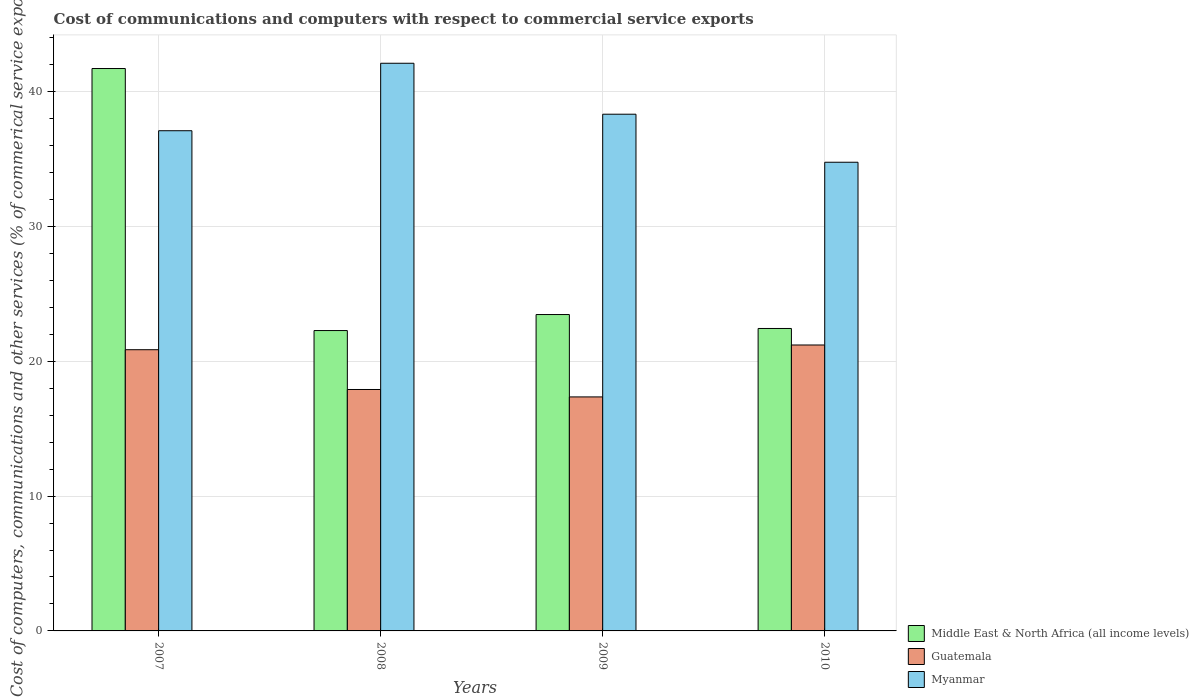How many groups of bars are there?
Your response must be concise. 4. What is the label of the 2nd group of bars from the left?
Keep it short and to the point. 2008. In how many cases, is the number of bars for a given year not equal to the number of legend labels?
Keep it short and to the point. 0. What is the cost of communications and computers in Guatemala in 2010?
Ensure brevity in your answer.  21.21. Across all years, what is the maximum cost of communications and computers in Myanmar?
Your response must be concise. 42.11. Across all years, what is the minimum cost of communications and computers in Middle East & North Africa (all income levels)?
Your answer should be very brief. 22.28. In which year was the cost of communications and computers in Myanmar minimum?
Provide a succinct answer. 2010. What is the total cost of communications and computers in Guatemala in the graph?
Your response must be concise. 77.34. What is the difference between the cost of communications and computers in Myanmar in 2008 and that in 2010?
Offer a very short reply. 7.34. What is the difference between the cost of communications and computers in Myanmar in 2008 and the cost of communications and computers in Middle East & North Africa (all income levels) in 2010?
Your answer should be very brief. 19.67. What is the average cost of communications and computers in Myanmar per year?
Make the answer very short. 38.08. In the year 2010, what is the difference between the cost of communications and computers in Myanmar and cost of communications and computers in Guatemala?
Your answer should be very brief. 13.56. In how many years, is the cost of communications and computers in Myanmar greater than 28 %?
Your response must be concise. 4. What is the ratio of the cost of communications and computers in Myanmar in 2008 to that in 2009?
Your response must be concise. 1.1. Is the cost of communications and computers in Myanmar in 2007 less than that in 2010?
Your answer should be very brief. No. Is the difference between the cost of communications and computers in Myanmar in 2007 and 2009 greater than the difference between the cost of communications and computers in Guatemala in 2007 and 2009?
Your response must be concise. No. What is the difference between the highest and the second highest cost of communications and computers in Myanmar?
Make the answer very short. 3.78. What is the difference between the highest and the lowest cost of communications and computers in Middle East & North Africa (all income levels)?
Your answer should be compact. 19.44. What does the 2nd bar from the left in 2010 represents?
Keep it short and to the point. Guatemala. What does the 2nd bar from the right in 2010 represents?
Your answer should be very brief. Guatemala. How many bars are there?
Your response must be concise. 12. Are all the bars in the graph horizontal?
Offer a terse response. No. How many years are there in the graph?
Provide a succinct answer. 4. Are the values on the major ticks of Y-axis written in scientific E-notation?
Your answer should be very brief. No. Does the graph contain grids?
Offer a very short reply. Yes. How are the legend labels stacked?
Your answer should be very brief. Vertical. What is the title of the graph?
Your response must be concise. Cost of communications and computers with respect to commercial service exports. What is the label or title of the X-axis?
Provide a succinct answer. Years. What is the label or title of the Y-axis?
Your answer should be compact. Cost of computers, communications and other services (% of commerical service exports). What is the Cost of computers, communications and other services (% of commerical service exports) in Middle East & North Africa (all income levels) in 2007?
Provide a short and direct response. 41.72. What is the Cost of computers, communications and other services (% of commerical service exports) of Guatemala in 2007?
Offer a very short reply. 20.86. What is the Cost of computers, communications and other services (% of commerical service exports) in Myanmar in 2007?
Provide a succinct answer. 37.11. What is the Cost of computers, communications and other services (% of commerical service exports) in Middle East & North Africa (all income levels) in 2008?
Provide a short and direct response. 22.28. What is the Cost of computers, communications and other services (% of commerical service exports) in Guatemala in 2008?
Provide a short and direct response. 17.91. What is the Cost of computers, communications and other services (% of commerical service exports) of Myanmar in 2008?
Keep it short and to the point. 42.11. What is the Cost of computers, communications and other services (% of commerical service exports) of Middle East & North Africa (all income levels) in 2009?
Give a very brief answer. 23.47. What is the Cost of computers, communications and other services (% of commerical service exports) in Guatemala in 2009?
Give a very brief answer. 17.36. What is the Cost of computers, communications and other services (% of commerical service exports) of Myanmar in 2009?
Provide a short and direct response. 38.33. What is the Cost of computers, communications and other services (% of commerical service exports) of Middle East & North Africa (all income levels) in 2010?
Your response must be concise. 22.44. What is the Cost of computers, communications and other services (% of commerical service exports) in Guatemala in 2010?
Give a very brief answer. 21.21. What is the Cost of computers, communications and other services (% of commerical service exports) in Myanmar in 2010?
Make the answer very short. 34.77. Across all years, what is the maximum Cost of computers, communications and other services (% of commerical service exports) in Middle East & North Africa (all income levels)?
Give a very brief answer. 41.72. Across all years, what is the maximum Cost of computers, communications and other services (% of commerical service exports) in Guatemala?
Ensure brevity in your answer.  21.21. Across all years, what is the maximum Cost of computers, communications and other services (% of commerical service exports) in Myanmar?
Keep it short and to the point. 42.11. Across all years, what is the minimum Cost of computers, communications and other services (% of commerical service exports) of Middle East & North Africa (all income levels)?
Keep it short and to the point. 22.28. Across all years, what is the minimum Cost of computers, communications and other services (% of commerical service exports) in Guatemala?
Provide a succinct answer. 17.36. Across all years, what is the minimum Cost of computers, communications and other services (% of commerical service exports) in Myanmar?
Offer a terse response. 34.77. What is the total Cost of computers, communications and other services (% of commerical service exports) in Middle East & North Africa (all income levels) in the graph?
Offer a very short reply. 109.91. What is the total Cost of computers, communications and other services (% of commerical service exports) in Guatemala in the graph?
Ensure brevity in your answer.  77.34. What is the total Cost of computers, communications and other services (% of commerical service exports) of Myanmar in the graph?
Ensure brevity in your answer.  152.31. What is the difference between the Cost of computers, communications and other services (% of commerical service exports) in Middle East & North Africa (all income levels) in 2007 and that in 2008?
Your answer should be compact. 19.44. What is the difference between the Cost of computers, communications and other services (% of commerical service exports) of Guatemala in 2007 and that in 2008?
Your response must be concise. 2.95. What is the difference between the Cost of computers, communications and other services (% of commerical service exports) of Myanmar in 2007 and that in 2008?
Provide a short and direct response. -5.01. What is the difference between the Cost of computers, communications and other services (% of commerical service exports) of Middle East & North Africa (all income levels) in 2007 and that in 2009?
Ensure brevity in your answer.  18.25. What is the difference between the Cost of computers, communications and other services (% of commerical service exports) in Guatemala in 2007 and that in 2009?
Provide a short and direct response. 3.5. What is the difference between the Cost of computers, communications and other services (% of commerical service exports) of Myanmar in 2007 and that in 2009?
Keep it short and to the point. -1.23. What is the difference between the Cost of computers, communications and other services (% of commerical service exports) of Middle East & North Africa (all income levels) in 2007 and that in 2010?
Your answer should be very brief. 19.28. What is the difference between the Cost of computers, communications and other services (% of commerical service exports) of Guatemala in 2007 and that in 2010?
Give a very brief answer. -0.35. What is the difference between the Cost of computers, communications and other services (% of commerical service exports) in Myanmar in 2007 and that in 2010?
Make the answer very short. 2.34. What is the difference between the Cost of computers, communications and other services (% of commerical service exports) of Middle East & North Africa (all income levels) in 2008 and that in 2009?
Your answer should be compact. -1.19. What is the difference between the Cost of computers, communications and other services (% of commerical service exports) in Guatemala in 2008 and that in 2009?
Ensure brevity in your answer.  0.55. What is the difference between the Cost of computers, communications and other services (% of commerical service exports) of Myanmar in 2008 and that in 2009?
Provide a succinct answer. 3.78. What is the difference between the Cost of computers, communications and other services (% of commerical service exports) of Middle East & North Africa (all income levels) in 2008 and that in 2010?
Give a very brief answer. -0.15. What is the difference between the Cost of computers, communications and other services (% of commerical service exports) of Guatemala in 2008 and that in 2010?
Give a very brief answer. -3.3. What is the difference between the Cost of computers, communications and other services (% of commerical service exports) of Myanmar in 2008 and that in 2010?
Your response must be concise. 7.34. What is the difference between the Cost of computers, communications and other services (% of commerical service exports) in Guatemala in 2009 and that in 2010?
Offer a very short reply. -3.85. What is the difference between the Cost of computers, communications and other services (% of commerical service exports) in Myanmar in 2009 and that in 2010?
Ensure brevity in your answer.  3.56. What is the difference between the Cost of computers, communications and other services (% of commerical service exports) of Middle East & North Africa (all income levels) in 2007 and the Cost of computers, communications and other services (% of commerical service exports) of Guatemala in 2008?
Your response must be concise. 23.81. What is the difference between the Cost of computers, communications and other services (% of commerical service exports) in Middle East & North Africa (all income levels) in 2007 and the Cost of computers, communications and other services (% of commerical service exports) in Myanmar in 2008?
Provide a succinct answer. -0.39. What is the difference between the Cost of computers, communications and other services (% of commerical service exports) of Guatemala in 2007 and the Cost of computers, communications and other services (% of commerical service exports) of Myanmar in 2008?
Keep it short and to the point. -21.25. What is the difference between the Cost of computers, communications and other services (% of commerical service exports) of Middle East & North Africa (all income levels) in 2007 and the Cost of computers, communications and other services (% of commerical service exports) of Guatemala in 2009?
Give a very brief answer. 24.36. What is the difference between the Cost of computers, communications and other services (% of commerical service exports) in Middle East & North Africa (all income levels) in 2007 and the Cost of computers, communications and other services (% of commerical service exports) in Myanmar in 2009?
Ensure brevity in your answer.  3.39. What is the difference between the Cost of computers, communications and other services (% of commerical service exports) in Guatemala in 2007 and the Cost of computers, communications and other services (% of commerical service exports) in Myanmar in 2009?
Offer a terse response. -17.47. What is the difference between the Cost of computers, communications and other services (% of commerical service exports) of Middle East & North Africa (all income levels) in 2007 and the Cost of computers, communications and other services (% of commerical service exports) of Guatemala in 2010?
Your response must be concise. 20.51. What is the difference between the Cost of computers, communications and other services (% of commerical service exports) of Middle East & North Africa (all income levels) in 2007 and the Cost of computers, communications and other services (% of commerical service exports) of Myanmar in 2010?
Give a very brief answer. 6.95. What is the difference between the Cost of computers, communications and other services (% of commerical service exports) in Guatemala in 2007 and the Cost of computers, communications and other services (% of commerical service exports) in Myanmar in 2010?
Provide a short and direct response. -13.91. What is the difference between the Cost of computers, communications and other services (% of commerical service exports) of Middle East & North Africa (all income levels) in 2008 and the Cost of computers, communications and other services (% of commerical service exports) of Guatemala in 2009?
Your answer should be very brief. 4.92. What is the difference between the Cost of computers, communications and other services (% of commerical service exports) in Middle East & North Africa (all income levels) in 2008 and the Cost of computers, communications and other services (% of commerical service exports) in Myanmar in 2009?
Provide a short and direct response. -16.05. What is the difference between the Cost of computers, communications and other services (% of commerical service exports) in Guatemala in 2008 and the Cost of computers, communications and other services (% of commerical service exports) in Myanmar in 2009?
Provide a succinct answer. -20.42. What is the difference between the Cost of computers, communications and other services (% of commerical service exports) of Middle East & North Africa (all income levels) in 2008 and the Cost of computers, communications and other services (% of commerical service exports) of Guatemala in 2010?
Give a very brief answer. 1.07. What is the difference between the Cost of computers, communications and other services (% of commerical service exports) in Middle East & North Africa (all income levels) in 2008 and the Cost of computers, communications and other services (% of commerical service exports) in Myanmar in 2010?
Your response must be concise. -12.48. What is the difference between the Cost of computers, communications and other services (% of commerical service exports) in Guatemala in 2008 and the Cost of computers, communications and other services (% of commerical service exports) in Myanmar in 2010?
Your answer should be compact. -16.86. What is the difference between the Cost of computers, communications and other services (% of commerical service exports) in Middle East & North Africa (all income levels) in 2009 and the Cost of computers, communications and other services (% of commerical service exports) in Guatemala in 2010?
Provide a short and direct response. 2.26. What is the difference between the Cost of computers, communications and other services (% of commerical service exports) in Middle East & North Africa (all income levels) in 2009 and the Cost of computers, communications and other services (% of commerical service exports) in Myanmar in 2010?
Your response must be concise. -11.3. What is the difference between the Cost of computers, communications and other services (% of commerical service exports) in Guatemala in 2009 and the Cost of computers, communications and other services (% of commerical service exports) in Myanmar in 2010?
Keep it short and to the point. -17.41. What is the average Cost of computers, communications and other services (% of commerical service exports) in Middle East & North Africa (all income levels) per year?
Your answer should be compact. 27.48. What is the average Cost of computers, communications and other services (% of commerical service exports) in Guatemala per year?
Provide a succinct answer. 19.34. What is the average Cost of computers, communications and other services (% of commerical service exports) of Myanmar per year?
Keep it short and to the point. 38.08. In the year 2007, what is the difference between the Cost of computers, communications and other services (% of commerical service exports) of Middle East & North Africa (all income levels) and Cost of computers, communications and other services (% of commerical service exports) of Guatemala?
Your response must be concise. 20.86. In the year 2007, what is the difference between the Cost of computers, communications and other services (% of commerical service exports) of Middle East & North Africa (all income levels) and Cost of computers, communications and other services (% of commerical service exports) of Myanmar?
Provide a short and direct response. 4.62. In the year 2007, what is the difference between the Cost of computers, communications and other services (% of commerical service exports) in Guatemala and Cost of computers, communications and other services (% of commerical service exports) in Myanmar?
Make the answer very short. -16.24. In the year 2008, what is the difference between the Cost of computers, communications and other services (% of commerical service exports) in Middle East & North Africa (all income levels) and Cost of computers, communications and other services (% of commerical service exports) in Guatemala?
Your response must be concise. 4.37. In the year 2008, what is the difference between the Cost of computers, communications and other services (% of commerical service exports) of Middle East & North Africa (all income levels) and Cost of computers, communications and other services (% of commerical service exports) of Myanmar?
Keep it short and to the point. -19.83. In the year 2008, what is the difference between the Cost of computers, communications and other services (% of commerical service exports) in Guatemala and Cost of computers, communications and other services (% of commerical service exports) in Myanmar?
Offer a very short reply. -24.2. In the year 2009, what is the difference between the Cost of computers, communications and other services (% of commerical service exports) of Middle East & North Africa (all income levels) and Cost of computers, communications and other services (% of commerical service exports) of Guatemala?
Provide a short and direct response. 6.11. In the year 2009, what is the difference between the Cost of computers, communications and other services (% of commerical service exports) of Middle East & North Africa (all income levels) and Cost of computers, communications and other services (% of commerical service exports) of Myanmar?
Your response must be concise. -14.86. In the year 2009, what is the difference between the Cost of computers, communications and other services (% of commerical service exports) of Guatemala and Cost of computers, communications and other services (% of commerical service exports) of Myanmar?
Make the answer very short. -20.97. In the year 2010, what is the difference between the Cost of computers, communications and other services (% of commerical service exports) of Middle East & North Africa (all income levels) and Cost of computers, communications and other services (% of commerical service exports) of Guatemala?
Keep it short and to the point. 1.23. In the year 2010, what is the difference between the Cost of computers, communications and other services (% of commerical service exports) in Middle East & North Africa (all income levels) and Cost of computers, communications and other services (% of commerical service exports) in Myanmar?
Your answer should be compact. -12.33. In the year 2010, what is the difference between the Cost of computers, communications and other services (% of commerical service exports) of Guatemala and Cost of computers, communications and other services (% of commerical service exports) of Myanmar?
Provide a short and direct response. -13.56. What is the ratio of the Cost of computers, communications and other services (% of commerical service exports) of Middle East & North Africa (all income levels) in 2007 to that in 2008?
Offer a very short reply. 1.87. What is the ratio of the Cost of computers, communications and other services (% of commerical service exports) of Guatemala in 2007 to that in 2008?
Ensure brevity in your answer.  1.16. What is the ratio of the Cost of computers, communications and other services (% of commerical service exports) of Myanmar in 2007 to that in 2008?
Your response must be concise. 0.88. What is the ratio of the Cost of computers, communications and other services (% of commerical service exports) in Middle East & North Africa (all income levels) in 2007 to that in 2009?
Give a very brief answer. 1.78. What is the ratio of the Cost of computers, communications and other services (% of commerical service exports) of Guatemala in 2007 to that in 2009?
Ensure brevity in your answer.  1.2. What is the ratio of the Cost of computers, communications and other services (% of commerical service exports) in Middle East & North Africa (all income levels) in 2007 to that in 2010?
Give a very brief answer. 1.86. What is the ratio of the Cost of computers, communications and other services (% of commerical service exports) in Guatemala in 2007 to that in 2010?
Your answer should be compact. 0.98. What is the ratio of the Cost of computers, communications and other services (% of commerical service exports) in Myanmar in 2007 to that in 2010?
Give a very brief answer. 1.07. What is the ratio of the Cost of computers, communications and other services (% of commerical service exports) in Middle East & North Africa (all income levels) in 2008 to that in 2009?
Give a very brief answer. 0.95. What is the ratio of the Cost of computers, communications and other services (% of commerical service exports) of Guatemala in 2008 to that in 2009?
Offer a very short reply. 1.03. What is the ratio of the Cost of computers, communications and other services (% of commerical service exports) in Myanmar in 2008 to that in 2009?
Provide a succinct answer. 1.1. What is the ratio of the Cost of computers, communications and other services (% of commerical service exports) of Middle East & North Africa (all income levels) in 2008 to that in 2010?
Your response must be concise. 0.99. What is the ratio of the Cost of computers, communications and other services (% of commerical service exports) in Guatemala in 2008 to that in 2010?
Ensure brevity in your answer.  0.84. What is the ratio of the Cost of computers, communications and other services (% of commerical service exports) of Myanmar in 2008 to that in 2010?
Keep it short and to the point. 1.21. What is the ratio of the Cost of computers, communications and other services (% of commerical service exports) of Middle East & North Africa (all income levels) in 2009 to that in 2010?
Provide a succinct answer. 1.05. What is the ratio of the Cost of computers, communications and other services (% of commerical service exports) of Guatemala in 2009 to that in 2010?
Your answer should be compact. 0.82. What is the ratio of the Cost of computers, communications and other services (% of commerical service exports) of Myanmar in 2009 to that in 2010?
Give a very brief answer. 1.1. What is the difference between the highest and the second highest Cost of computers, communications and other services (% of commerical service exports) of Middle East & North Africa (all income levels)?
Your response must be concise. 18.25. What is the difference between the highest and the second highest Cost of computers, communications and other services (% of commerical service exports) in Guatemala?
Your answer should be very brief. 0.35. What is the difference between the highest and the second highest Cost of computers, communications and other services (% of commerical service exports) in Myanmar?
Give a very brief answer. 3.78. What is the difference between the highest and the lowest Cost of computers, communications and other services (% of commerical service exports) in Middle East & North Africa (all income levels)?
Keep it short and to the point. 19.44. What is the difference between the highest and the lowest Cost of computers, communications and other services (% of commerical service exports) in Guatemala?
Offer a terse response. 3.85. What is the difference between the highest and the lowest Cost of computers, communications and other services (% of commerical service exports) in Myanmar?
Your answer should be very brief. 7.34. 